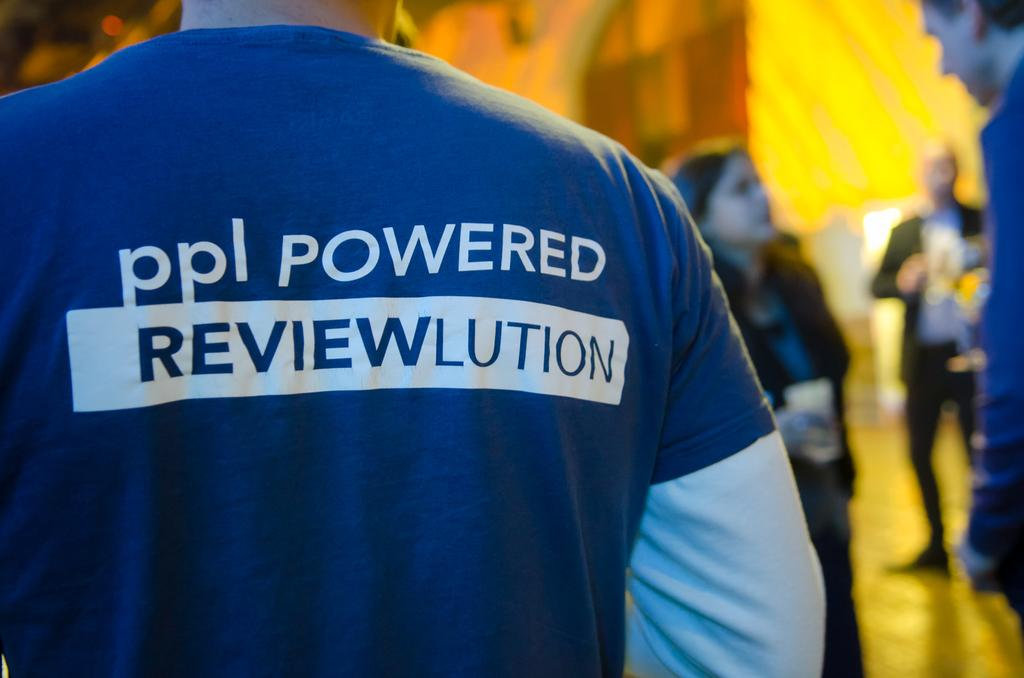Provide a one-sentence caption for the provided image. Man standing in a picture with a ppl powered reviewlution shirt on. 